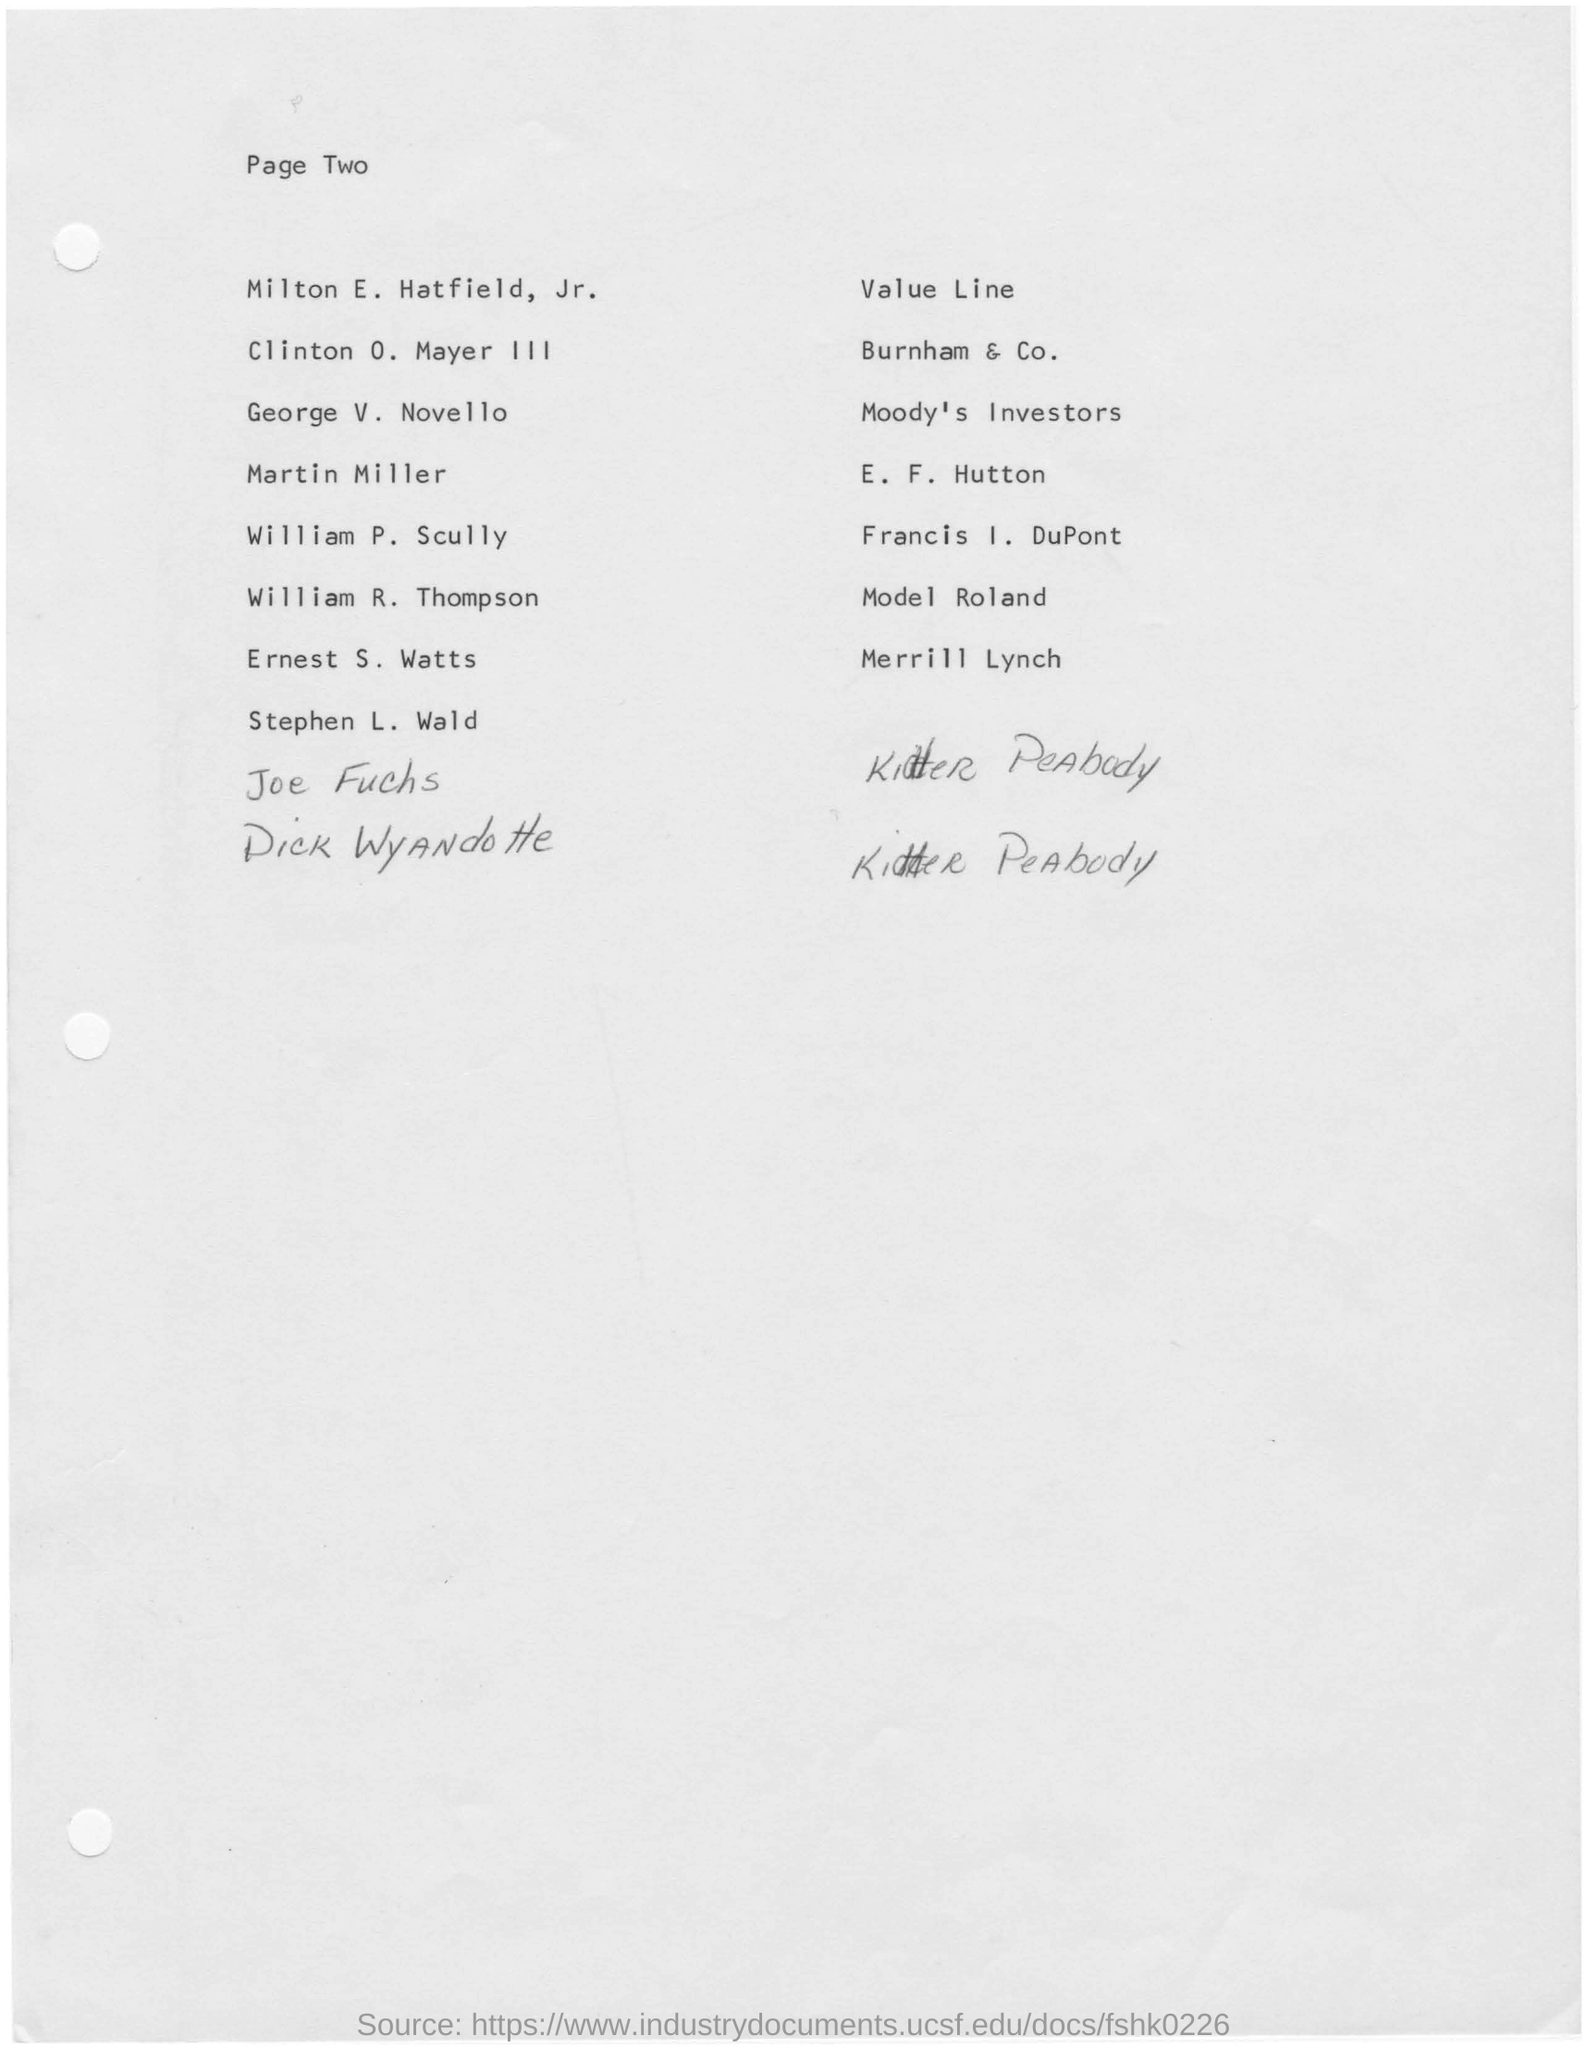What is the page no mentioned in this document?
Ensure brevity in your answer.  Two. What is written in top of the Page ?
Ensure brevity in your answer.  Page two. 